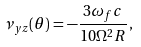Convert formula to latex. <formula><loc_0><loc_0><loc_500><loc_500>\nu _ { y z } ( \theta ) = - \frac { 3 \omega _ { f } c } { 1 0 \Omega ^ { 2 } R } \, ,</formula> 